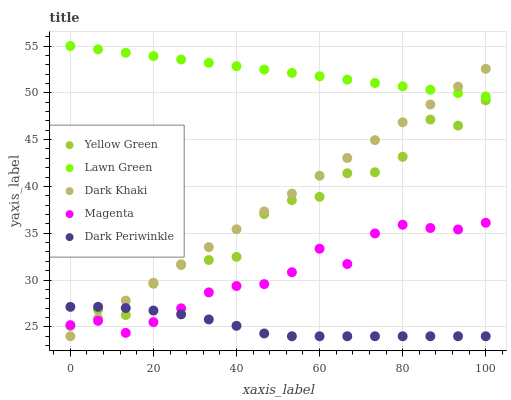Does Dark Periwinkle have the minimum area under the curve?
Answer yes or no. Yes. Does Lawn Green have the maximum area under the curve?
Answer yes or no. Yes. Does Magenta have the minimum area under the curve?
Answer yes or no. No. Does Magenta have the maximum area under the curve?
Answer yes or no. No. Is Dark Khaki the smoothest?
Answer yes or no. Yes. Is Yellow Green the roughest?
Answer yes or no. Yes. Is Lawn Green the smoothest?
Answer yes or no. No. Is Lawn Green the roughest?
Answer yes or no. No. Does Dark Khaki have the lowest value?
Answer yes or no. Yes. Does Magenta have the lowest value?
Answer yes or no. No. Does Lawn Green have the highest value?
Answer yes or no. Yes. Does Magenta have the highest value?
Answer yes or no. No. Is Magenta less than Lawn Green?
Answer yes or no. Yes. Is Lawn Green greater than Yellow Green?
Answer yes or no. Yes. Does Magenta intersect Dark Periwinkle?
Answer yes or no. Yes. Is Magenta less than Dark Periwinkle?
Answer yes or no. No. Is Magenta greater than Dark Periwinkle?
Answer yes or no. No. Does Magenta intersect Lawn Green?
Answer yes or no. No. 